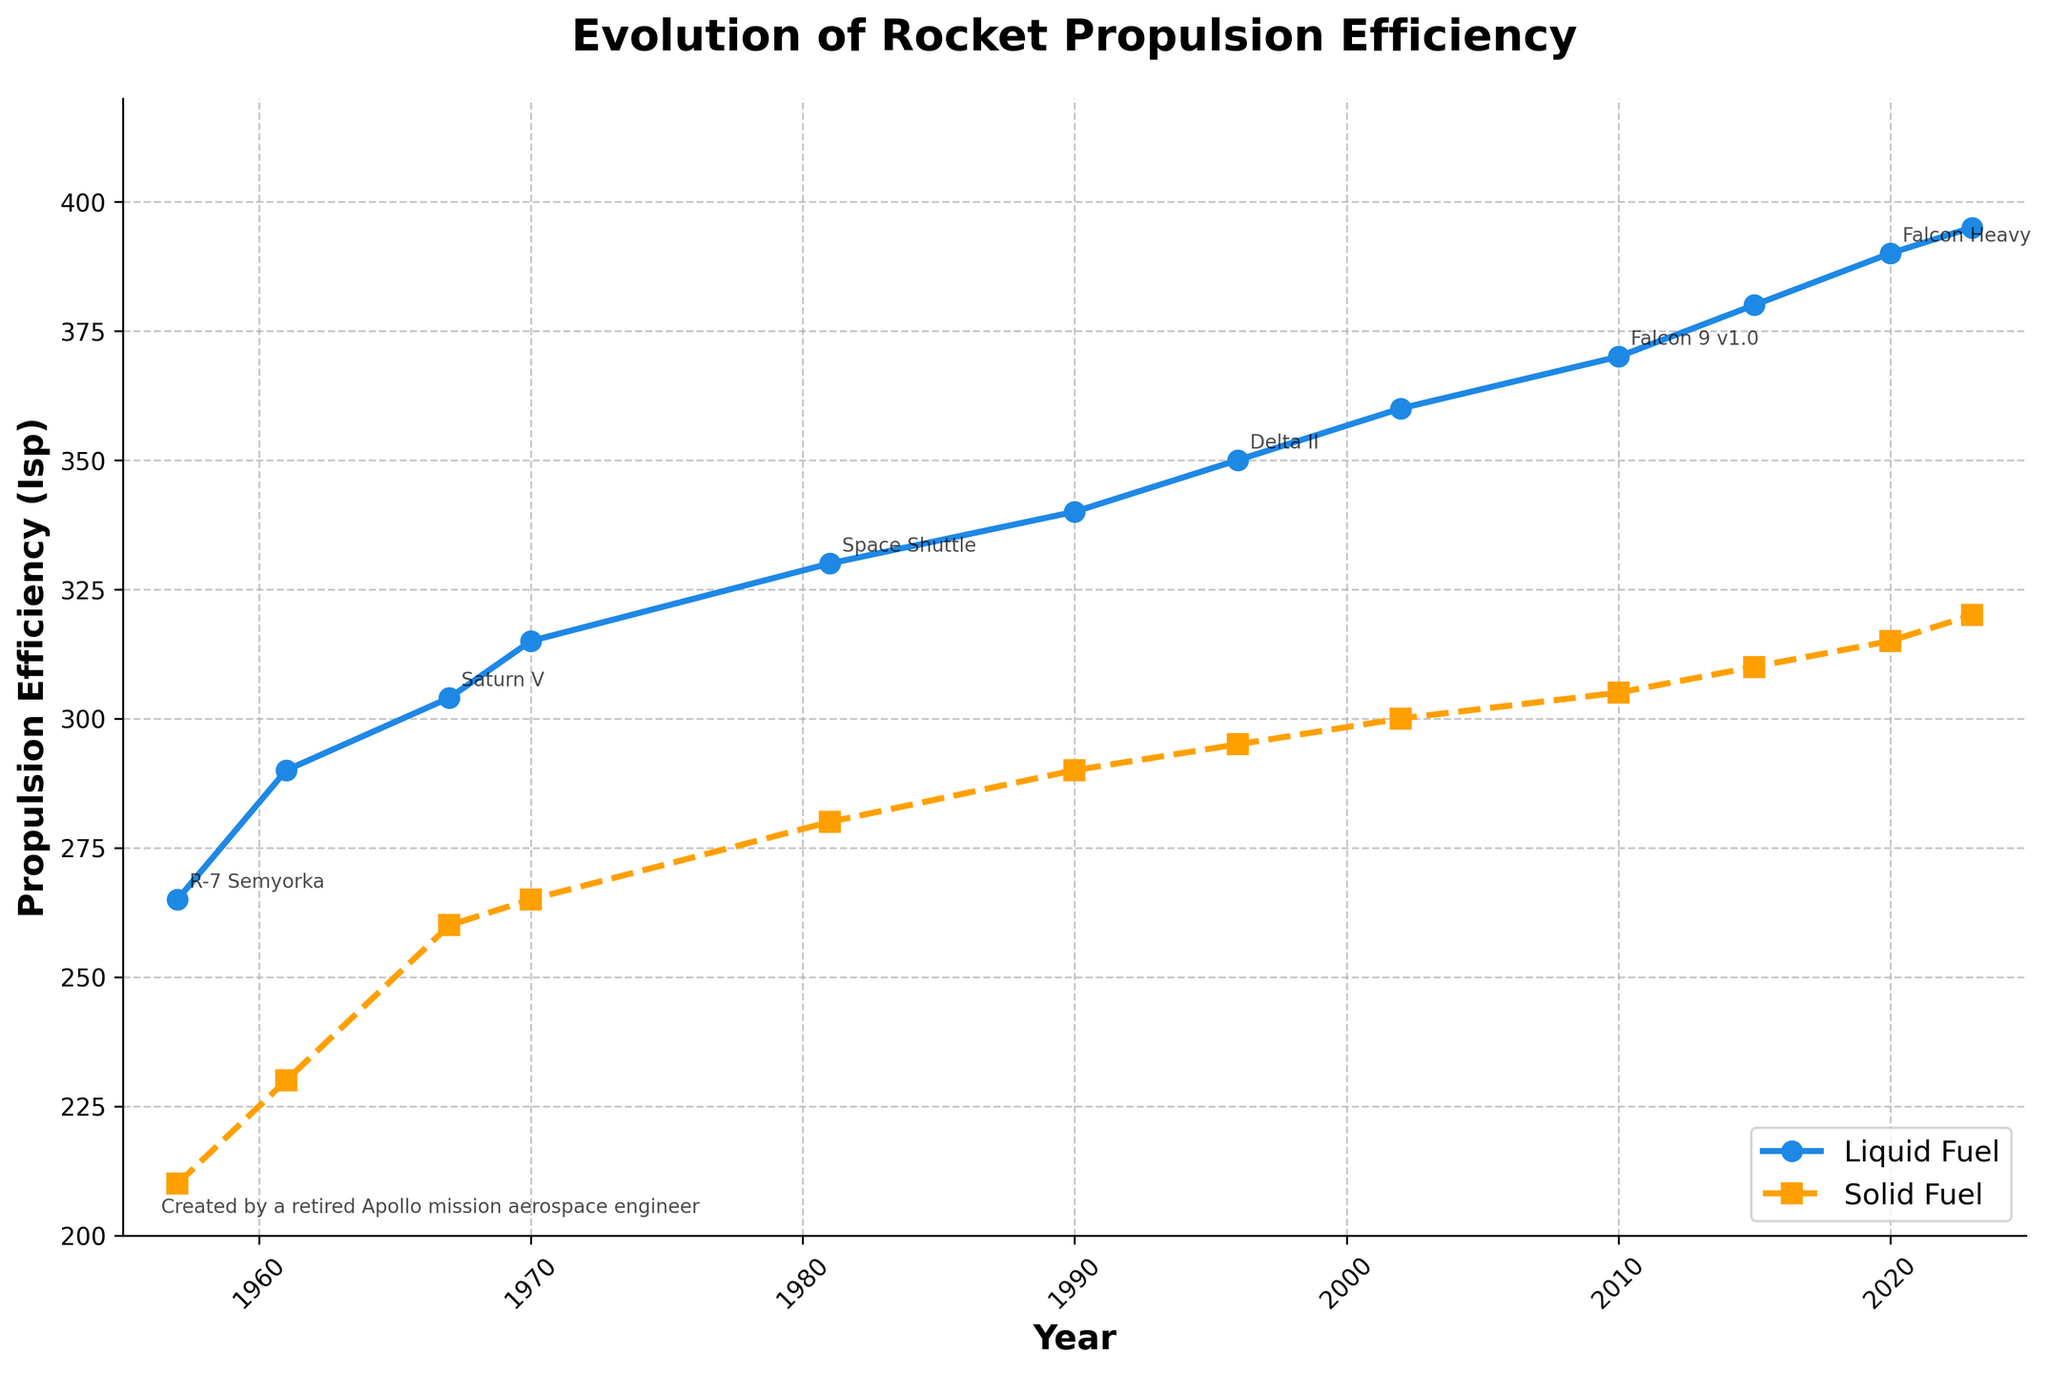Which type of fuel showed a higher efficiency in 1967? To determine the fuel type with higher efficiency in 1967, we look at the y-axis values for that year. The data points on the solid and dashed lines (representing liquid and solid fuels respectively) show the propulsion efficiency. In 1967, the liquid fuel has an efficiency of 304 Isp, while the solid fuel has 260 Isp. Therefore, liquid fuel showed higher efficiency.
Answer: Liquid fuel What is the difference in efficiency between liquid fuel and solid fuel in 2023? To find the difference, we identify the efficiencies for both fuel types in 2023 from the chart. Liquid fuel has an efficiency of 395 Isp, and solid fuel has 320 Isp. The difference is calculated as 395 - 320 = 75 Isp.
Answer: 75 Isp How did the efficiency of solid fuel change from 1981 to 2023? To see the change over time, we check the efficiency values for solid fuel in 1981 and 2023. In 1981, it is 280 Isp, and in 2023, it is 320 Isp. The change is calculated as 320 - 280 = 40 Isp.
Answer: Increased by 40 Isp Which year shows the smallest gap between the efficiencies of liquid and solid fuels? We need to observe the differences between the two lines (liquid and solid fuel efficiencies) for each year. By comparing the gaps, 1970 has a gap of 50 Isp (315 - 265), which is the smallest compared to other years.
Answer: 1970 What was the approximate average efficiency of solid fuel from 1957 to 2023? To find the average, we sum the solid fuel efficiencies and divide by the number of data points. Solid fuel efficiencies are: 210, 230, 260, 265, 280, 290, 295, 300, 305, 310, 315, 320. The sum is 3580, dividing by 12 gives approximately 298.33 Isp.
Answer: 298.33 Isp Between which consecutive years did liquid fuel efficiency increase the most? We compare the increases between each consecutive year for liquid fuel efficiencies. The largest increase occurs between 1967 (304 Isp) and 1970 (315 Isp), giving an increase of 11 Isp.
Answer: 1967 to 1970 What is the trend in propulsion efficiency for both liquid and solid fuels over the shown period? Observing the overall pattern of both lines, the efficiencies of both liquid and solid fuels increase over time, indicating a trend of improving propulsion efficiency in both types over the years.
Answer: Increasing trend Which notable rocket corresponds to the liquid fuel efficiency of 370 Isp? We look for the point on the liquid fuel efficiency line where the value is 370 Isp. According to the annotations on the chart, this corresponds to the Falcon 9 v1.0 launched in 2010.
Answer: Falcon 9 v1.0 By how much did the solid fuel efficiency increase from the Saturn I to the Space Shuttle era? The solid fuel efficiency for Saturn I (1961) is 230 Isp, and for the Space Shuttle (1981) it is 280 Isp. The increase can be calculated as 280 - 230 = 50 Isp.
Answer: 50 Isp What’s the highest efficiency achieved by either fuel type in the data set? Checking the topmost points of both lines, the highest efficiency recorded is for liquid fuel in 2023, which is 395 Isp.
Answer: 395 Isp 